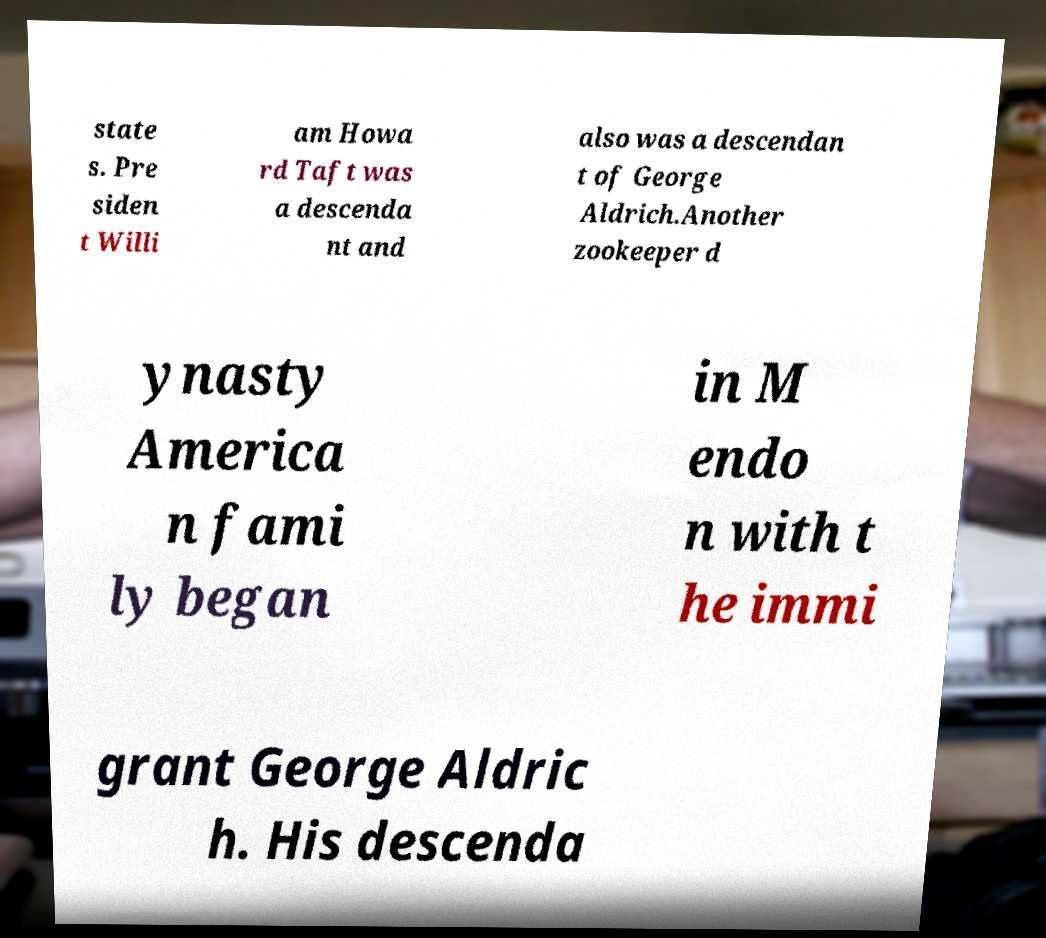For documentation purposes, I need the text within this image transcribed. Could you provide that? state s. Pre siden t Willi am Howa rd Taft was a descenda nt and also was a descendan t of George Aldrich.Another zookeeper d ynasty America n fami ly began in M endo n with t he immi grant George Aldric h. His descenda 